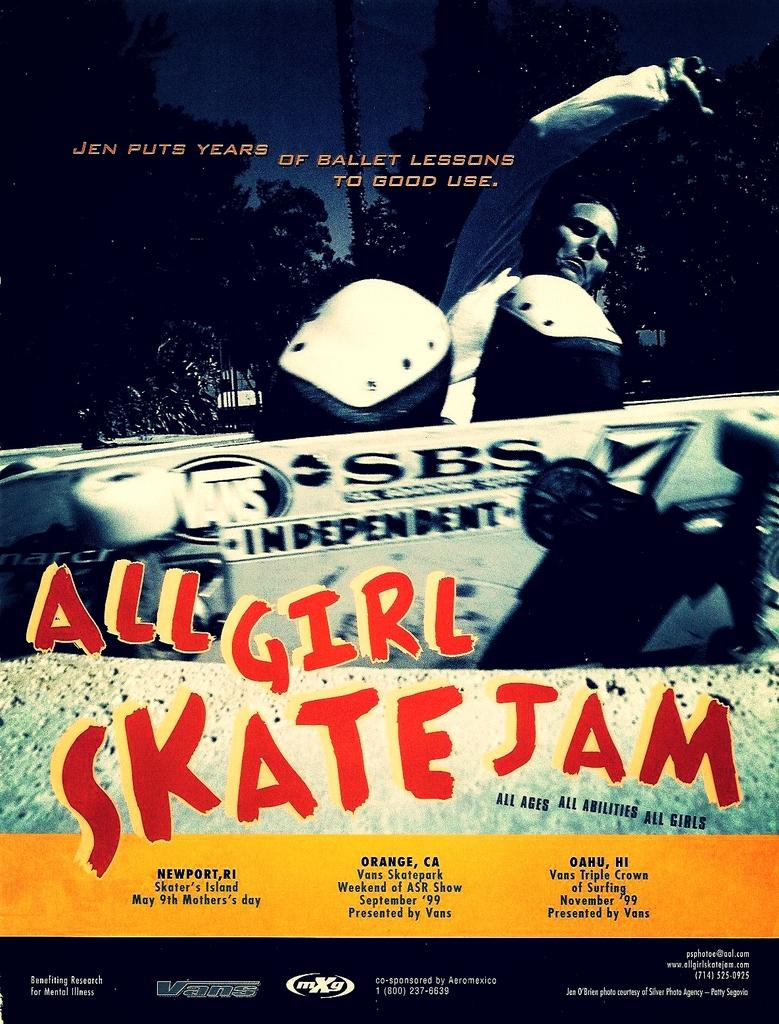<image>
Create a compact narrative representing the image presented. The event is called All Girl Skate Jam. 